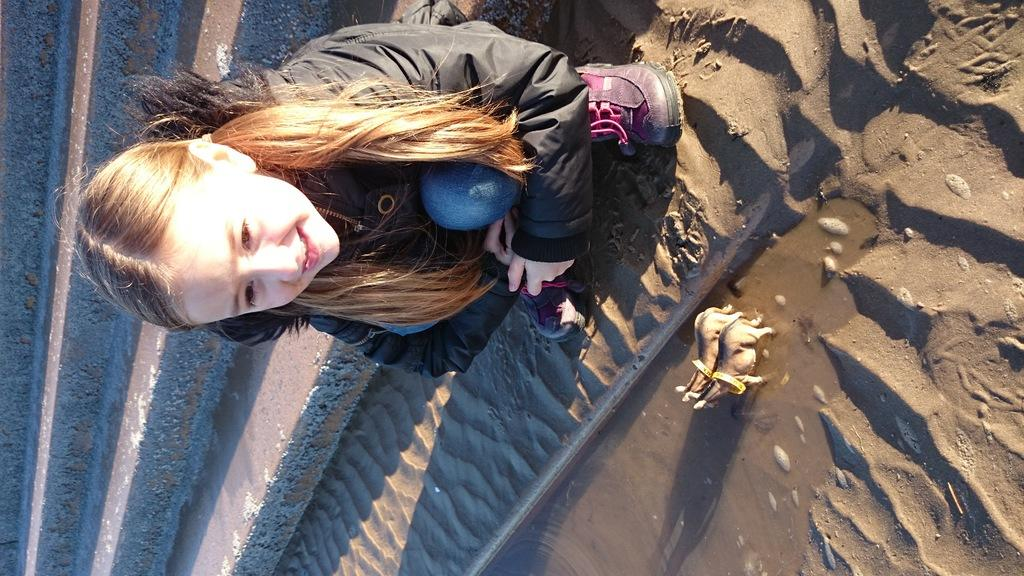What animals can be seen in the water in the image? There are two horses in the water in the image. What is the girl in the background doing? The girl is in a squat position in the background. What architectural feature is visible in the background? There is a staircase in the background. What type of terrain is present in the background? There is sand in the background. Reasoning: Let's think step by step by step in order to produce the conversation. We start by identifying the main subjects in the image, which are the two horses in the water. Then, we expand the conversation to include other elements in the image, such as the girl in the squat position, the staircase, and the sand. Each question is designed to elicit a specific detail about the image that is known from the provided facts. Absurd Question/Answer: Where is the nest of the rare bird species located in the image? There is no nest or rare bird species present in the image. What type of selection process is being conducted by the horses in the image? There is no selection process being conducted by the horses in the image; they are simply in the water. 